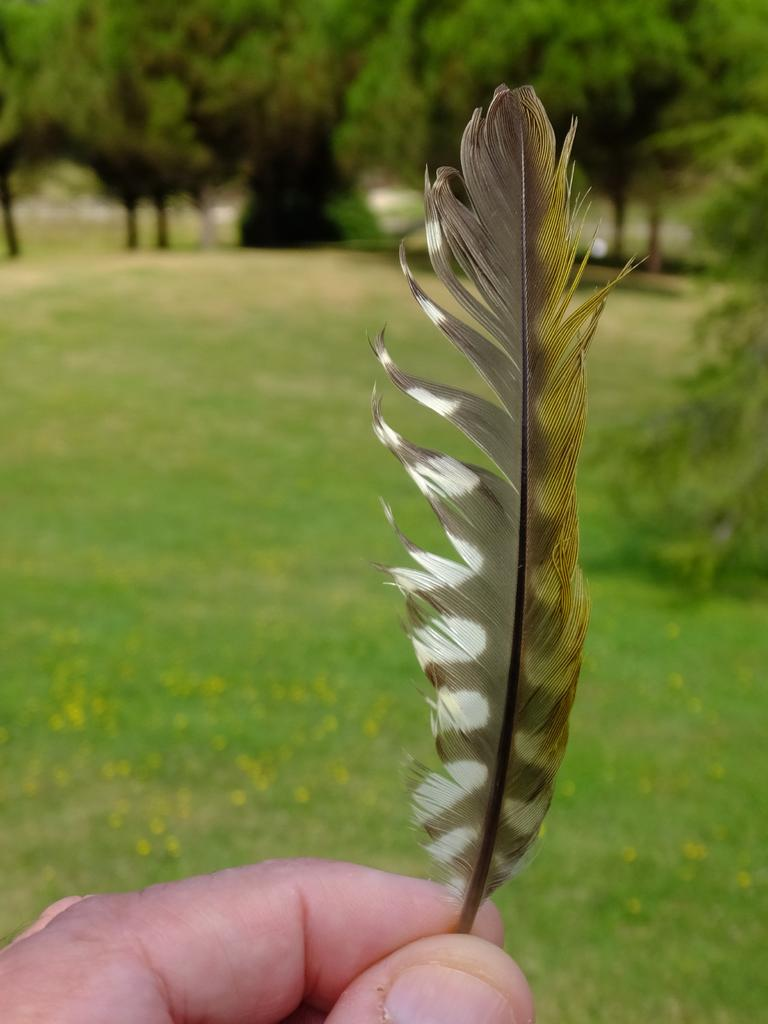What body parts are visible in the image? There are human fingers in the image. What object can be seen alongside the fingers? There is a feather in the image. How would you describe the background of the image? The background of the image is blurred. What type of natural environment is visible in the image? There is grass, plants, and trees visible in the image. What type of dust can be seen covering the feather in the image? There is no dust visible on the feather in the image. What type of fuel is being used by the person holding the feather in the image? There is no indication of any fuel being used in the image. 